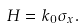<formula> <loc_0><loc_0><loc_500><loc_500>H = k _ { 0 } \sigma _ { x } .</formula> 